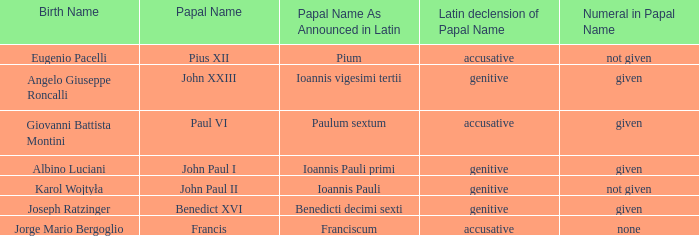What is the declension of the papal name for pope paul vi? Accusative. 